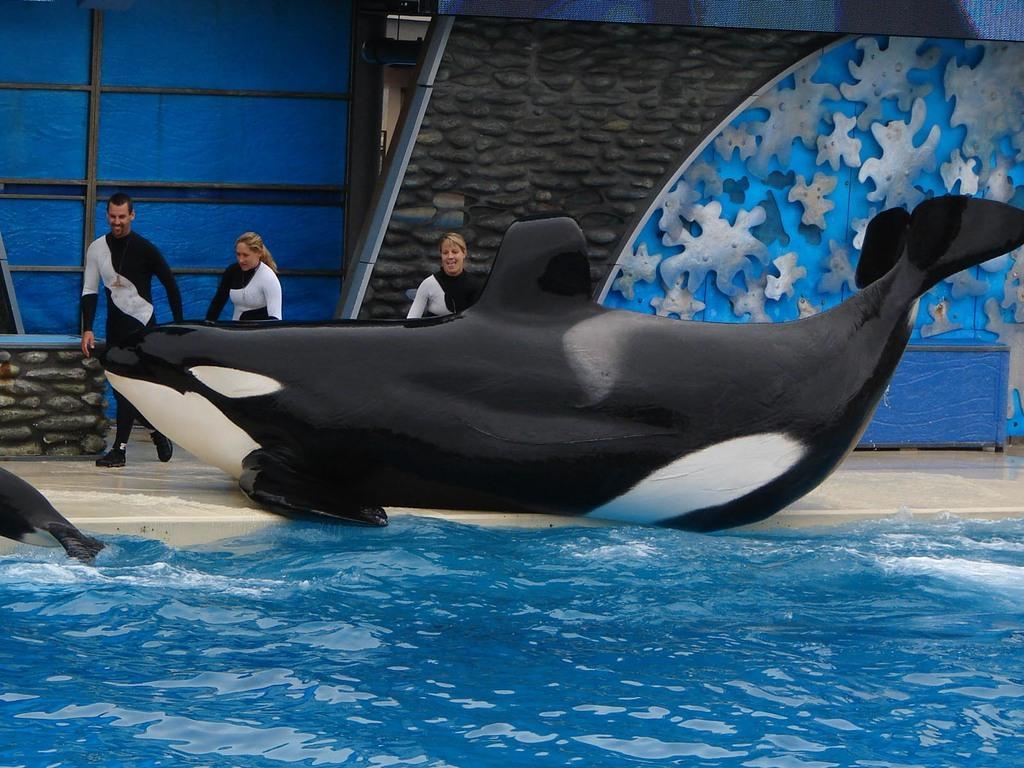Please provide a concise description of this image. In this image I can see two fishes, water and fence. In the background I can see three persons, wall and metal rods. This image is taken may be during a day. 